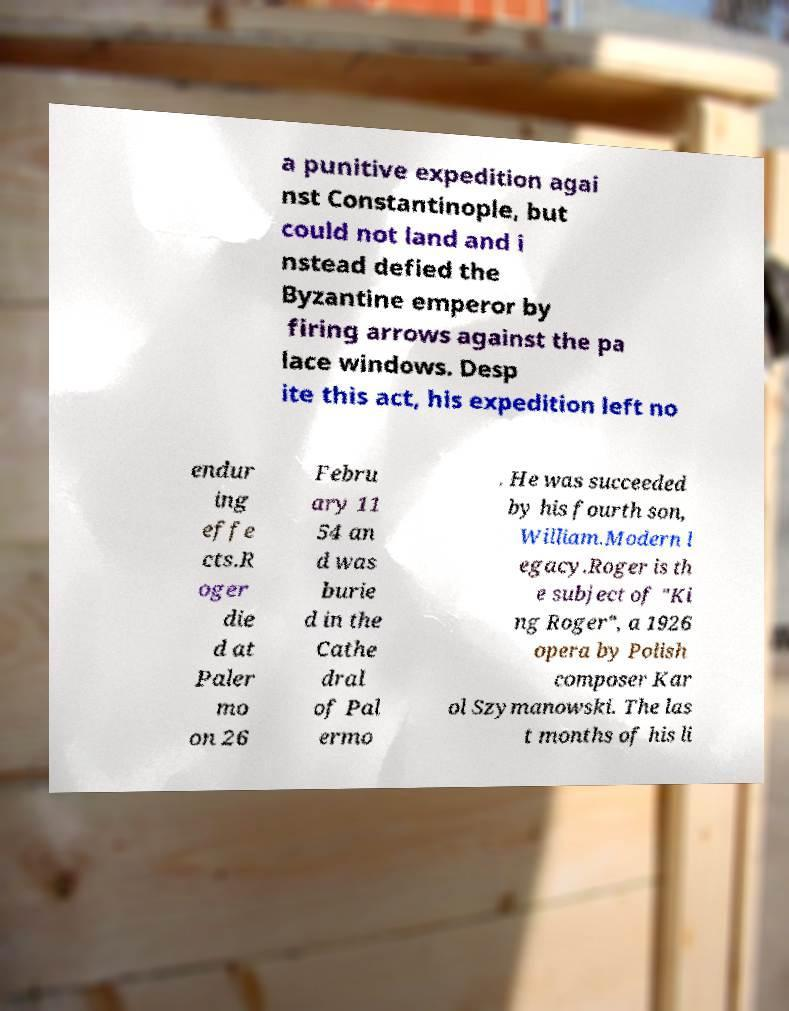Please read and relay the text visible in this image. What does it say? a punitive expedition agai nst Constantinople, but could not land and i nstead defied the Byzantine emperor by firing arrows against the pa lace windows. Desp ite this act, his expedition left no endur ing effe cts.R oger die d at Paler mo on 26 Febru ary 11 54 an d was burie d in the Cathe dral of Pal ermo . He was succeeded by his fourth son, William.Modern l egacy.Roger is th e subject of "Ki ng Roger", a 1926 opera by Polish composer Kar ol Szymanowski. The las t months of his li 